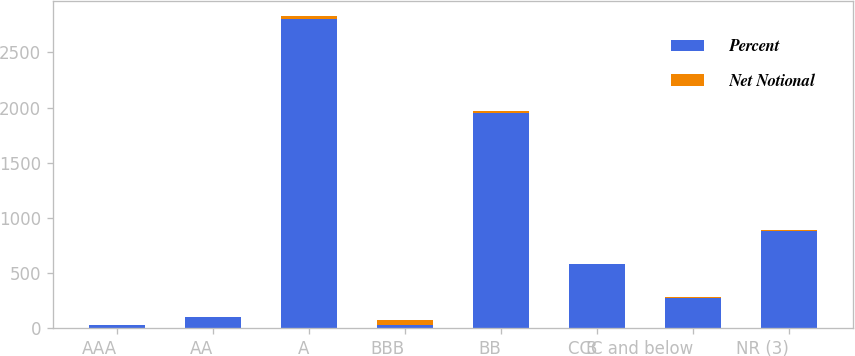<chart> <loc_0><loc_0><loc_500><loc_500><stacked_bar_chart><ecel><fcel>AAA<fcel>AA<fcel>A<fcel>BBB<fcel>BB<fcel>B<fcel>CCC and below<fcel>NR (3)<nl><fcel>Percent<fcel>30<fcel>103<fcel>2800<fcel>30<fcel>1948<fcel>579<fcel>278<fcel>880<nl><fcel>Net Notional<fcel>0.3<fcel>1.1<fcel>29<fcel>50.2<fcel>20.2<fcel>6<fcel>2.9<fcel>9.1<nl></chart> 